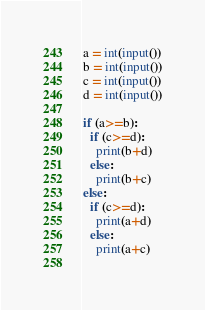Convert code to text. <code><loc_0><loc_0><loc_500><loc_500><_Python_>a = int(input())
b = int(input())
c = int(input())
d = int(input())

if (a>=b):
  if (c>=d):
    print(b+d)
  else:
    print(b+c)
else:
  if (c>=d):
    print(a+d)
  else:
    print(a+c)
      
</code> 